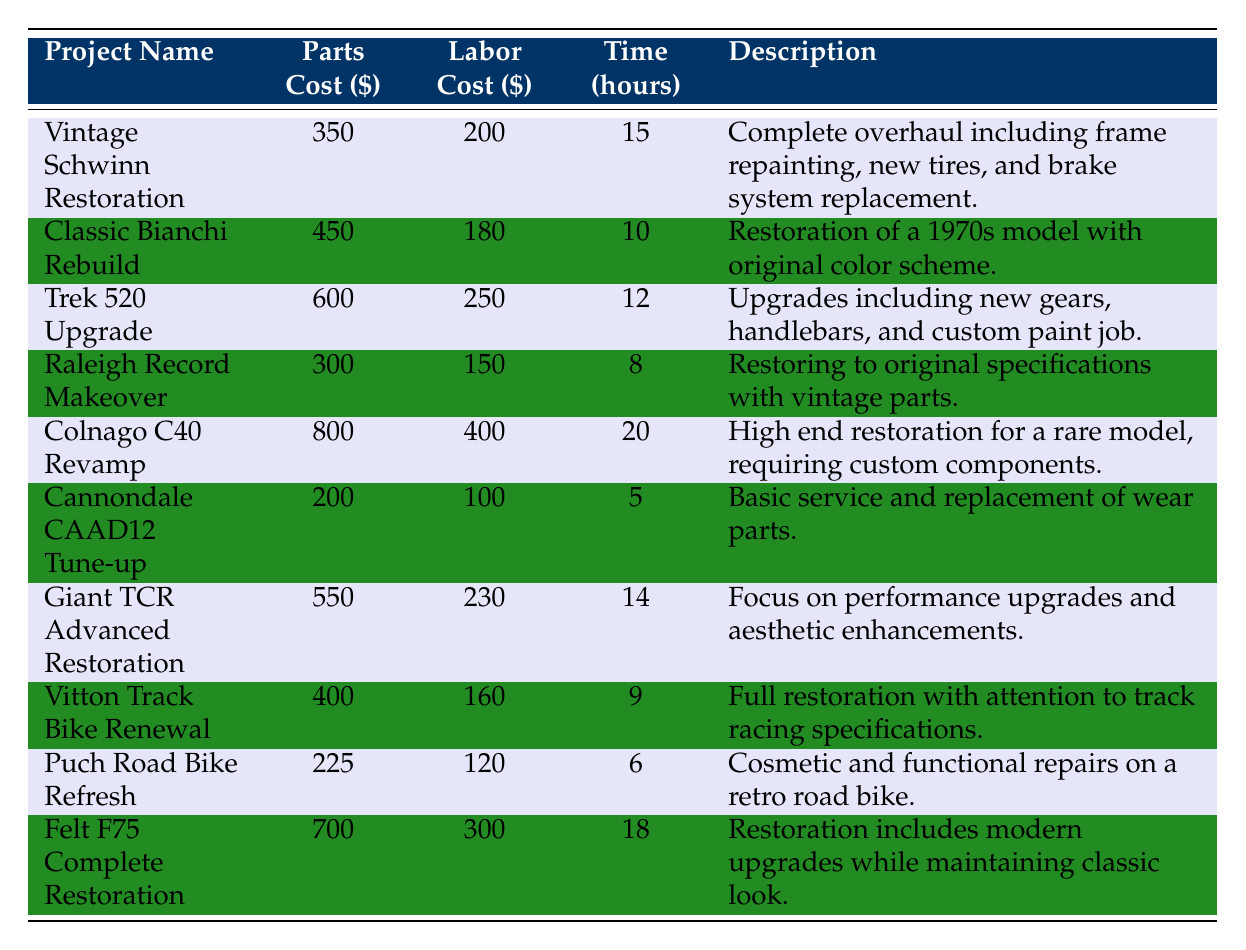What is the parts cost for the Cannondale CAAD12 Tune-up? The table shows the parts cost for the Cannondale CAAD12 Tune-up in the second column. It is stated as 200.
Answer: 200 Which restoration project had the highest labor cost? By examining the labor costs listed, the Colnago C40 Revamp has the highest labor cost at 400.
Answer: Colnago C40 Revamp How much time, in hours, was invested in the Felt F75 Complete Restoration? The time invested for the Felt F75 Complete Restoration can be found in the table under the time invested hours column, which is 18.
Answer: 18 What is the total cost (parts + labor) of the Vintage Schwinn Restoration? The parts cost for the Vintage Schwinn Restoration is 350 and the labor cost is 200. Adding them together, 350 + 200 = 550.
Answer: 550 What project took the least amount of time to complete? Reviewing the time invested hours in the table, the Cannondale CAAD12 Tune-up took the least time at 5 hours.
Answer: Cannondale CAAD12 Tune-up Is the parts cost for the Classic Bianchi Rebuild greater than $400? The parts cost for the Classic Bianchi Rebuild is 450, which is indeed greater than 400.
Answer: Yes What is the average parts cost for all listed bike restoration projects? The total parts cost can be calculated as (350 + 450 + 600 + 300 + 800 + 200 + 550 + 400 + 225 + 700) = 5,075. There are 10 projects, so the average parts cost is 5,075 / 10 = 507.5.
Answer: 507.5 Which project has the lowest total cost, and what is that cost? The total cost for each project can be calculated and compared. The Puch Road Bike Refresh has a parts cost of 225 and a labor cost of 120, giving a total of 225 + 120 = 345, which is the lowest.
Answer: Puch Road Bike Refresh, 345 How many projects required more than 15 hours of labor? Examining the time invested hours, only the Colnago C40 Revamp (20 hours) and the Felt F75 Complete Restoration (18 hours) required more than 15 hours of labor. Thus, there are 2 projects.
Answer: 2 Which restoration project had both the lowest parts cost and labor cost? Looking at the table, the Cannondale CAAD12 Tune-up has the lowest parts cost (200) and the lowest labor cost (100).
Answer: Cannondale CAAD12 Tune-up 